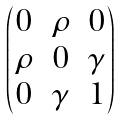<formula> <loc_0><loc_0><loc_500><loc_500>\begin{pmatrix} 0 & \rho & 0 \\ \rho & 0 & \gamma \\ 0 & \gamma & 1 \end{pmatrix}</formula> 